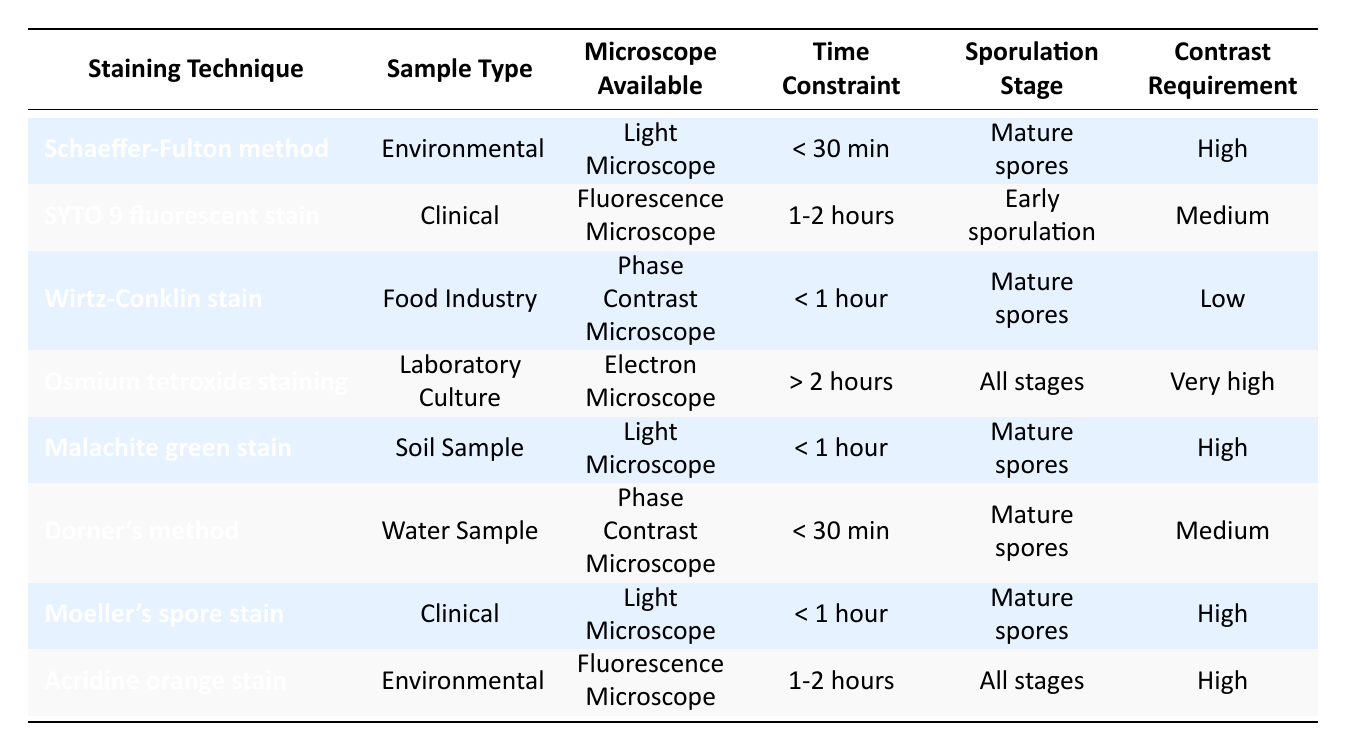What staining technique is recommended for environmental samples with mature spores and high contrast requirements? The table shows that for environmental samples with mature spores and high contrast requirement, the recommended staining technique is the Schaeffer-Fulton method.
Answer: Schaeffer-Fulton method Which microscope is available for the SYTO 9 fluorescent stain? According to the table, the SYTO 9 fluorescent stain requires a fluorescence microscope.
Answer: Fluorescence Microscope How many staining techniques listed can be used with a light microscope? By reviewing the table, the staining techniques that can be used with a light microscope are Schaeffer-Fulton method, Moeller's spore stain, and Malachite green stain. Therefore, the total count is 3.
Answer: 3 Is there a staining technique for laboratory cultures that takes more than 2 hours? The table indicates that Osmium tetroxide staining is the only technique listed for laboratory cultures that requires more than 2 hours. Therefore, the answer is yes.
Answer: Yes Which staining technique should be used for clinical samples that require low contrast and take less than 1 hour? The table shows that there is no staining technique specified for clinical samples that meet both the low contrast and less than 1 hour criteria. Therefore, the answer is no.
Answer: No What is the contrast requirement for the Wirtz-Conklin stain? The contrast requirement for the Wirtz-Conklin stain, as indicated in the table, is low.
Answer: Low How many staining techniques are suitable for mature spores across all sample types? The techniques suitable for mature spores are Schaeffer-Fulton method, Wirtz-Conklin stain, Malachite green stain, Dorner's method, and Moeller's spore stain. There are a total of 5 techniques.
Answer: 5 If you have a water sample and need to identify mature spores quickly, which technique should you use? The Dorner's method is listed in the table as the staining technique for water samples with mature spores that also takes less than 30 minutes, thus it is the appropriate choice.
Answer: Dorner's method What staining techniques allow for the visualization of sporulation in all stages? The table lists two staining techniques suitable for all sporulation stages: Osmium tetroxide staining for laboratory cultures and Acridine orange stain for environmental samples.
Answer: 2 